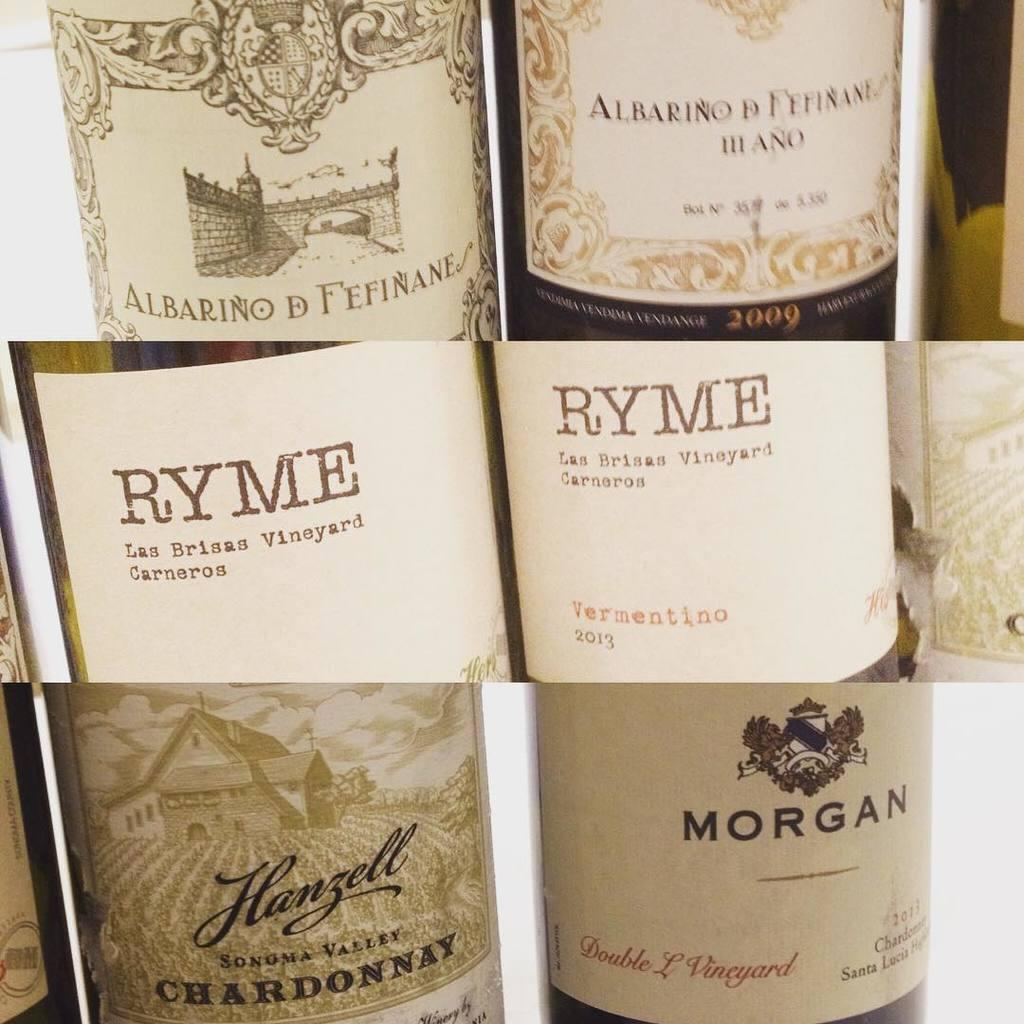Provide a one-sentence caption for the provided image. An assortment of wine including one from Ryme and another from Morgan. 